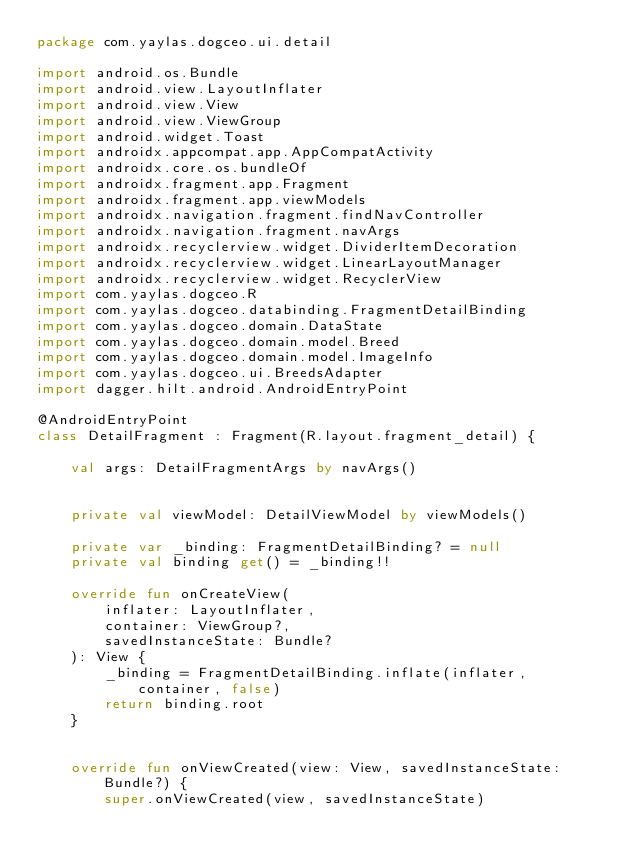Convert code to text. <code><loc_0><loc_0><loc_500><loc_500><_Kotlin_>package com.yaylas.dogceo.ui.detail

import android.os.Bundle
import android.view.LayoutInflater
import android.view.View
import android.view.ViewGroup
import android.widget.Toast
import androidx.appcompat.app.AppCompatActivity
import androidx.core.os.bundleOf
import androidx.fragment.app.Fragment
import androidx.fragment.app.viewModels
import androidx.navigation.fragment.findNavController
import androidx.navigation.fragment.navArgs
import androidx.recyclerview.widget.DividerItemDecoration
import androidx.recyclerview.widget.LinearLayoutManager
import androidx.recyclerview.widget.RecyclerView
import com.yaylas.dogceo.R
import com.yaylas.dogceo.databinding.FragmentDetailBinding
import com.yaylas.dogceo.domain.DataState
import com.yaylas.dogceo.domain.model.Breed
import com.yaylas.dogceo.domain.model.ImageInfo
import com.yaylas.dogceo.ui.BreedsAdapter
import dagger.hilt.android.AndroidEntryPoint

@AndroidEntryPoint
class DetailFragment : Fragment(R.layout.fragment_detail) {

    val args: DetailFragmentArgs by navArgs()


    private val viewModel: DetailViewModel by viewModels()

    private var _binding: FragmentDetailBinding? = null
    private val binding get() = _binding!!

    override fun onCreateView(
        inflater: LayoutInflater,
        container: ViewGroup?,
        savedInstanceState: Bundle?
    ): View {
        _binding = FragmentDetailBinding.inflate(inflater, container, false)
        return binding.root
    }


    override fun onViewCreated(view: View, savedInstanceState: Bundle?) {
        super.onViewCreated(view, savedInstanceState)</code> 